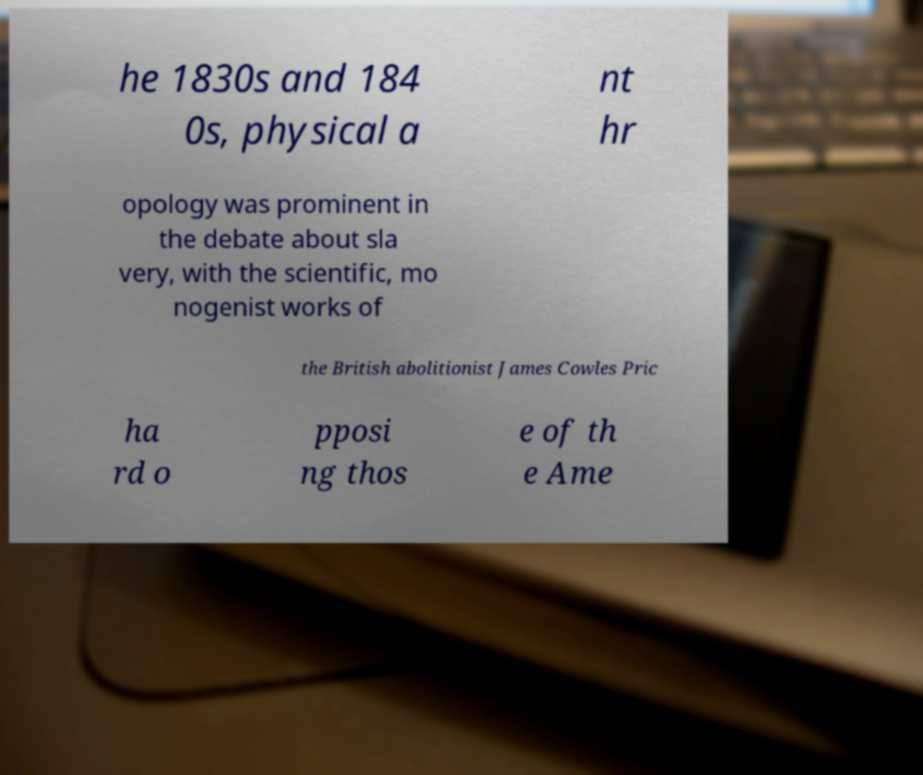Please read and relay the text visible in this image. What does it say? he 1830s and 184 0s, physical a nt hr opology was prominent in the debate about sla very, with the scientific, mo nogenist works of the British abolitionist James Cowles Pric ha rd o pposi ng thos e of th e Ame 